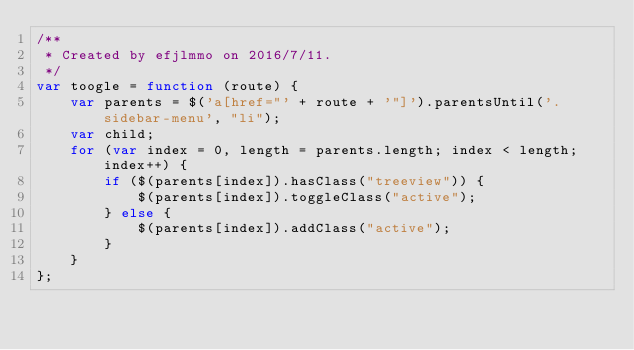<code> <loc_0><loc_0><loc_500><loc_500><_JavaScript_>/**
 * Created by efjlmmo on 2016/7/11.
 */
var toogle = function (route) {
    var parents = $('a[href="' + route + '"]').parentsUntil('.sidebar-menu', "li");
    var child;
    for (var index = 0, length = parents.length; index < length; index++) {
        if ($(parents[index]).hasClass("treeview")) {
            $(parents[index]).toggleClass("active");
        } else {
            $(parents[index]).addClass("active");
        }
    }
};</code> 